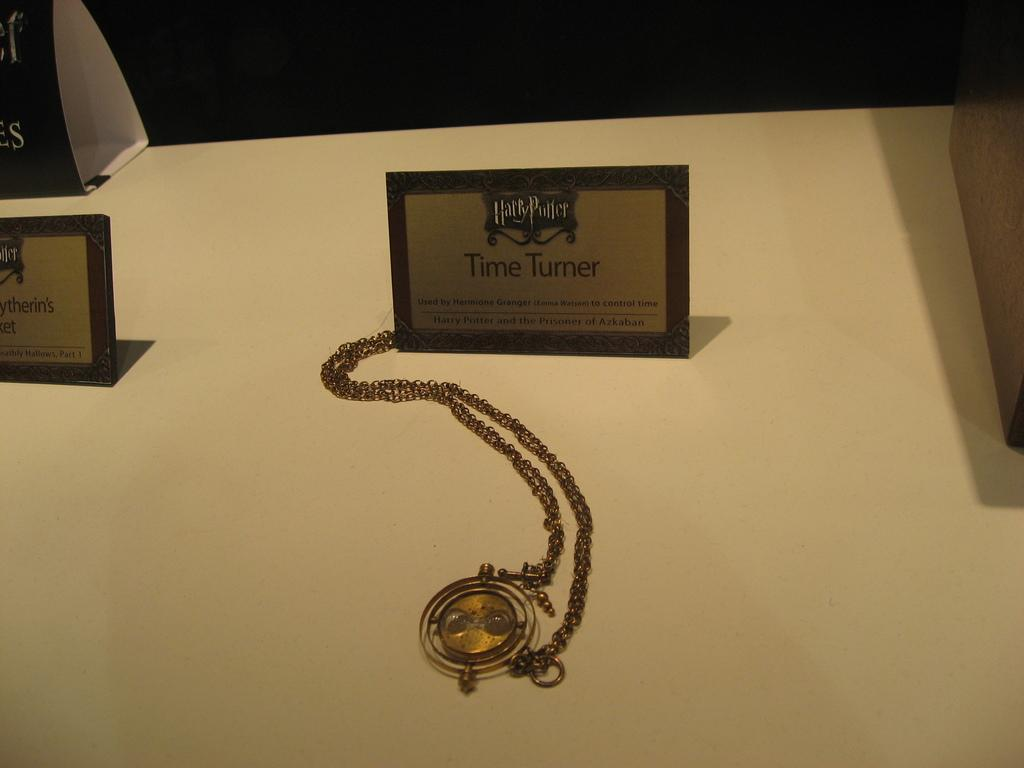<image>
Offer a succinct explanation of the picture presented. A gold Time Turner on a chain from Harry Potter. 